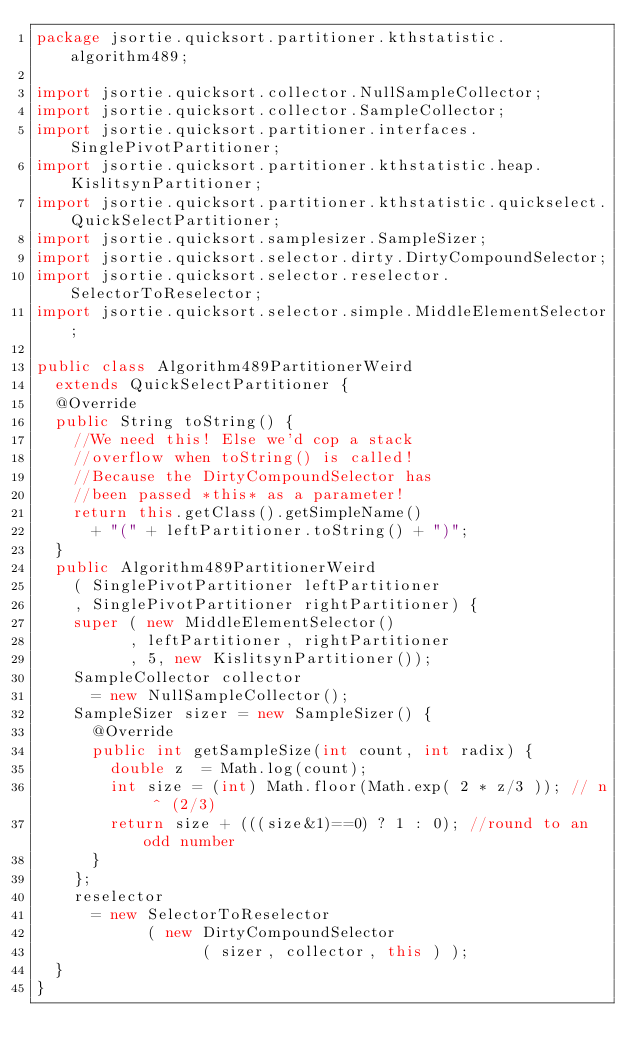Convert code to text. <code><loc_0><loc_0><loc_500><loc_500><_Java_>package jsortie.quicksort.partitioner.kthstatistic.algorithm489;

import jsortie.quicksort.collector.NullSampleCollector;
import jsortie.quicksort.collector.SampleCollector;
import jsortie.quicksort.partitioner.interfaces.SinglePivotPartitioner;
import jsortie.quicksort.partitioner.kthstatistic.heap.KislitsynPartitioner;
import jsortie.quicksort.partitioner.kthstatistic.quickselect.QuickSelectPartitioner;
import jsortie.quicksort.samplesizer.SampleSizer;
import jsortie.quicksort.selector.dirty.DirtyCompoundSelector;
import jsortie.quicksort.selector.reselector.SelectorToReselector;
import jsortie.quicksort.selector.simple.MiddleElementSelector;

public class Algorithm489PartitionerWeird 
  extends QuickSelectPartitioner {
  @Override
  public String toString() {
    //We need this! Else we'd cop a stack 
    //overflow when toString() is called!
    //Because the DirtyCompoundSelector has 
    //been passed *this* as a parameter!
    return this.getClass().getSimpleName() 
      + "(" + leftPartitioner.toString() + ")";
  }
  public Algorithm489PartitionerWeird
    ( SinglePivotPartitioner leftPartitioner
    , SinglePivotPartitioner rightPartitioner) {
    super ( new MiddleElementSelector()
          , leftPartitioner, rightPartitioner
          , 5, new KislitsynPartitioner());
    SampleCollector collector 
      = new NullSampleCollector();
    SampleSizer sizer = new SampleSizer() {
      @Override
      public int getSampleSize(int count, int radix) {
        double z  = Math.log(count);
        int size = (int) Math.floor(Math.exp( 2 * z/3 )); // n ^ (2/3)
        return size + (((size&1)==0) ? 1 : 0); //round to an odd number
      }
    };
    reselector 
      = new SelectorToReselector
            ( new DirtyCompoundSelector
                  ( sizer, collector, this ) );
  }
}
</code> 